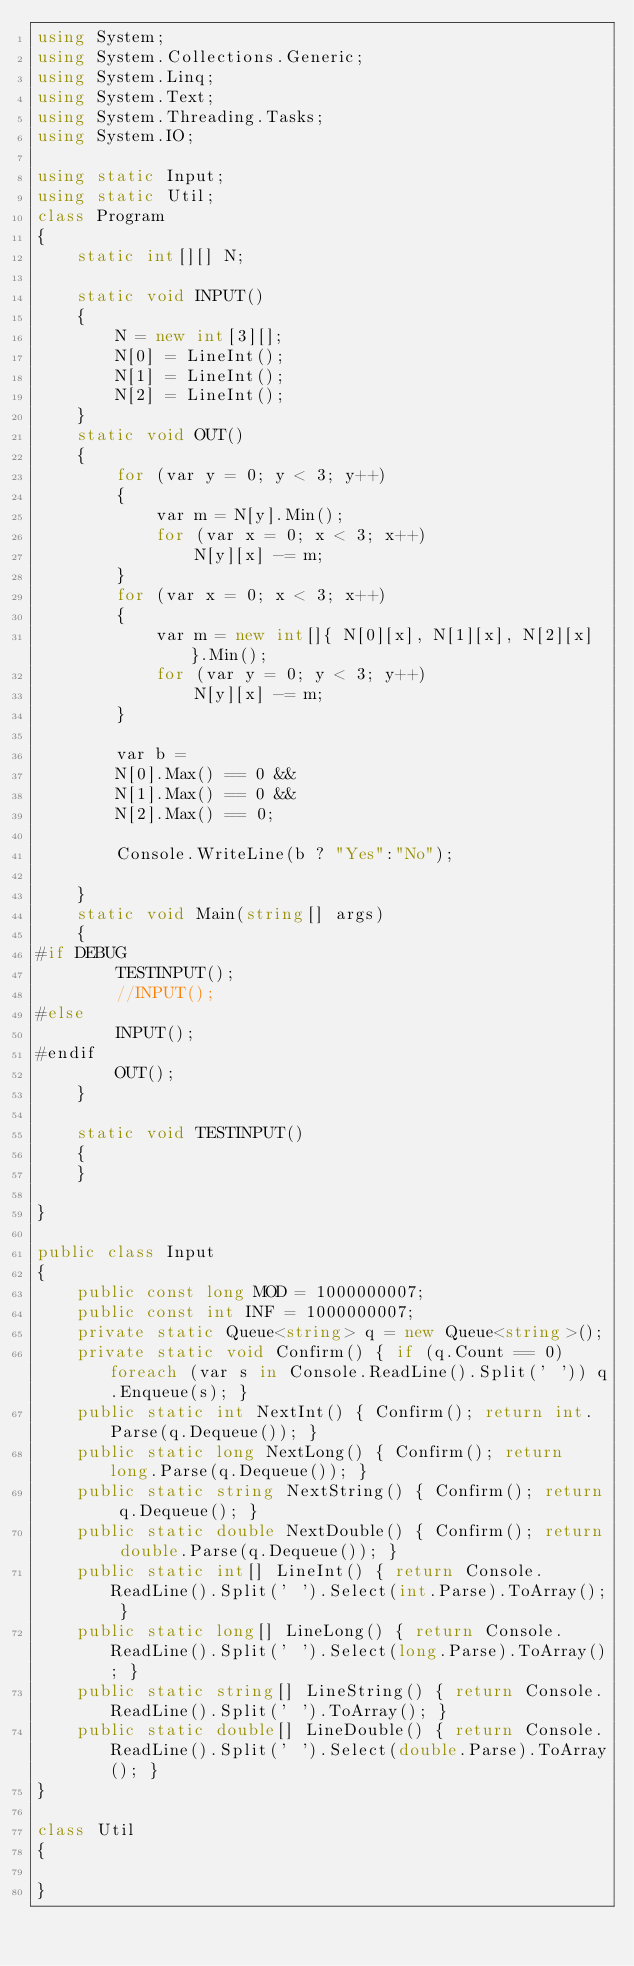<code> <loc_0><loc_0><loc_500><loc_500><_C#_>using System;
using System.Collections.Generic;
using System.Linq;
using System.Text;
using System.Threading.Tasks;
using System.IO;

using static Input;
using static Util;
class Program
{
    static int[][] N;

    static void INPUT()
    {
        N = new int[3][];
        N[0] = LineInt();
        N[1] = LineInt();
        N[2] = LineInt();
    }
    static void OUT()
    {
        for (var y = 0; y < 3; y++)
        {
            var m = N[y].Min();
            for (var x = 0; x < 3; x++)
                N[y][x] -= m;
        }
        for (var x = 0; x < 3; x++)
        {
            var m = new int[]{ N[0][x], N[1][x], N[2][x] }.Min();
            for (var y = 0; y < 3; y++)
                N[y][x] -= m;
        }

        var b =
        N[0].Max() == 0 &&
        N[1].Max() == 0 &&
        N[2].Max() == 0;

        Console.WriteLine(b ? "Yes":"No");

    }
    static void Main(string[] args)
    {
#if DEBUG  
        TESTINPUT();
        //INPUT();
#else
        INPUT();
#endif
        OUT();
    }

    static void TESTINPUT()
    {
    }

}

public class Input
{
    public const long MOD = 1000000007;
    public const int INF = 1000000007;
    private static Queue<string> q = new Queue<string>();
    private static void Confirm() { if (q.Count == 0) foreach (var s in Console.ReadLine().Split(' ')) q.Enqueue(s); }
    public static int NextInt() { Confirm(); return int.Parse(q.Dequeue()); }
    public static long NextLong() { Confirm(); return long.Parse(q.Dequeue()); }
    public static string NextString() { Confirm(); return q.Dequeue(); }
    public static double NextDouble() { Confirm(); return double.Parse(q.Dequeue()); }
    public static int[] LineInt() { return Console.ReadLine().Split(' ').Select(int.Parse).ToArray(); }
    public static long[] LineLong() { return Console.ReadLine().Split(' ').Select(long.Parse).ToArray(); }
    public static string[] LineString() { return Console.ReadLine().Split(' ').ToArray(); }
    public static double[] LineDouble() { return Console.ReadLine().Split(' ').Select(double.Parse).ToArray(); }
}

class Util
{

}


</code> 